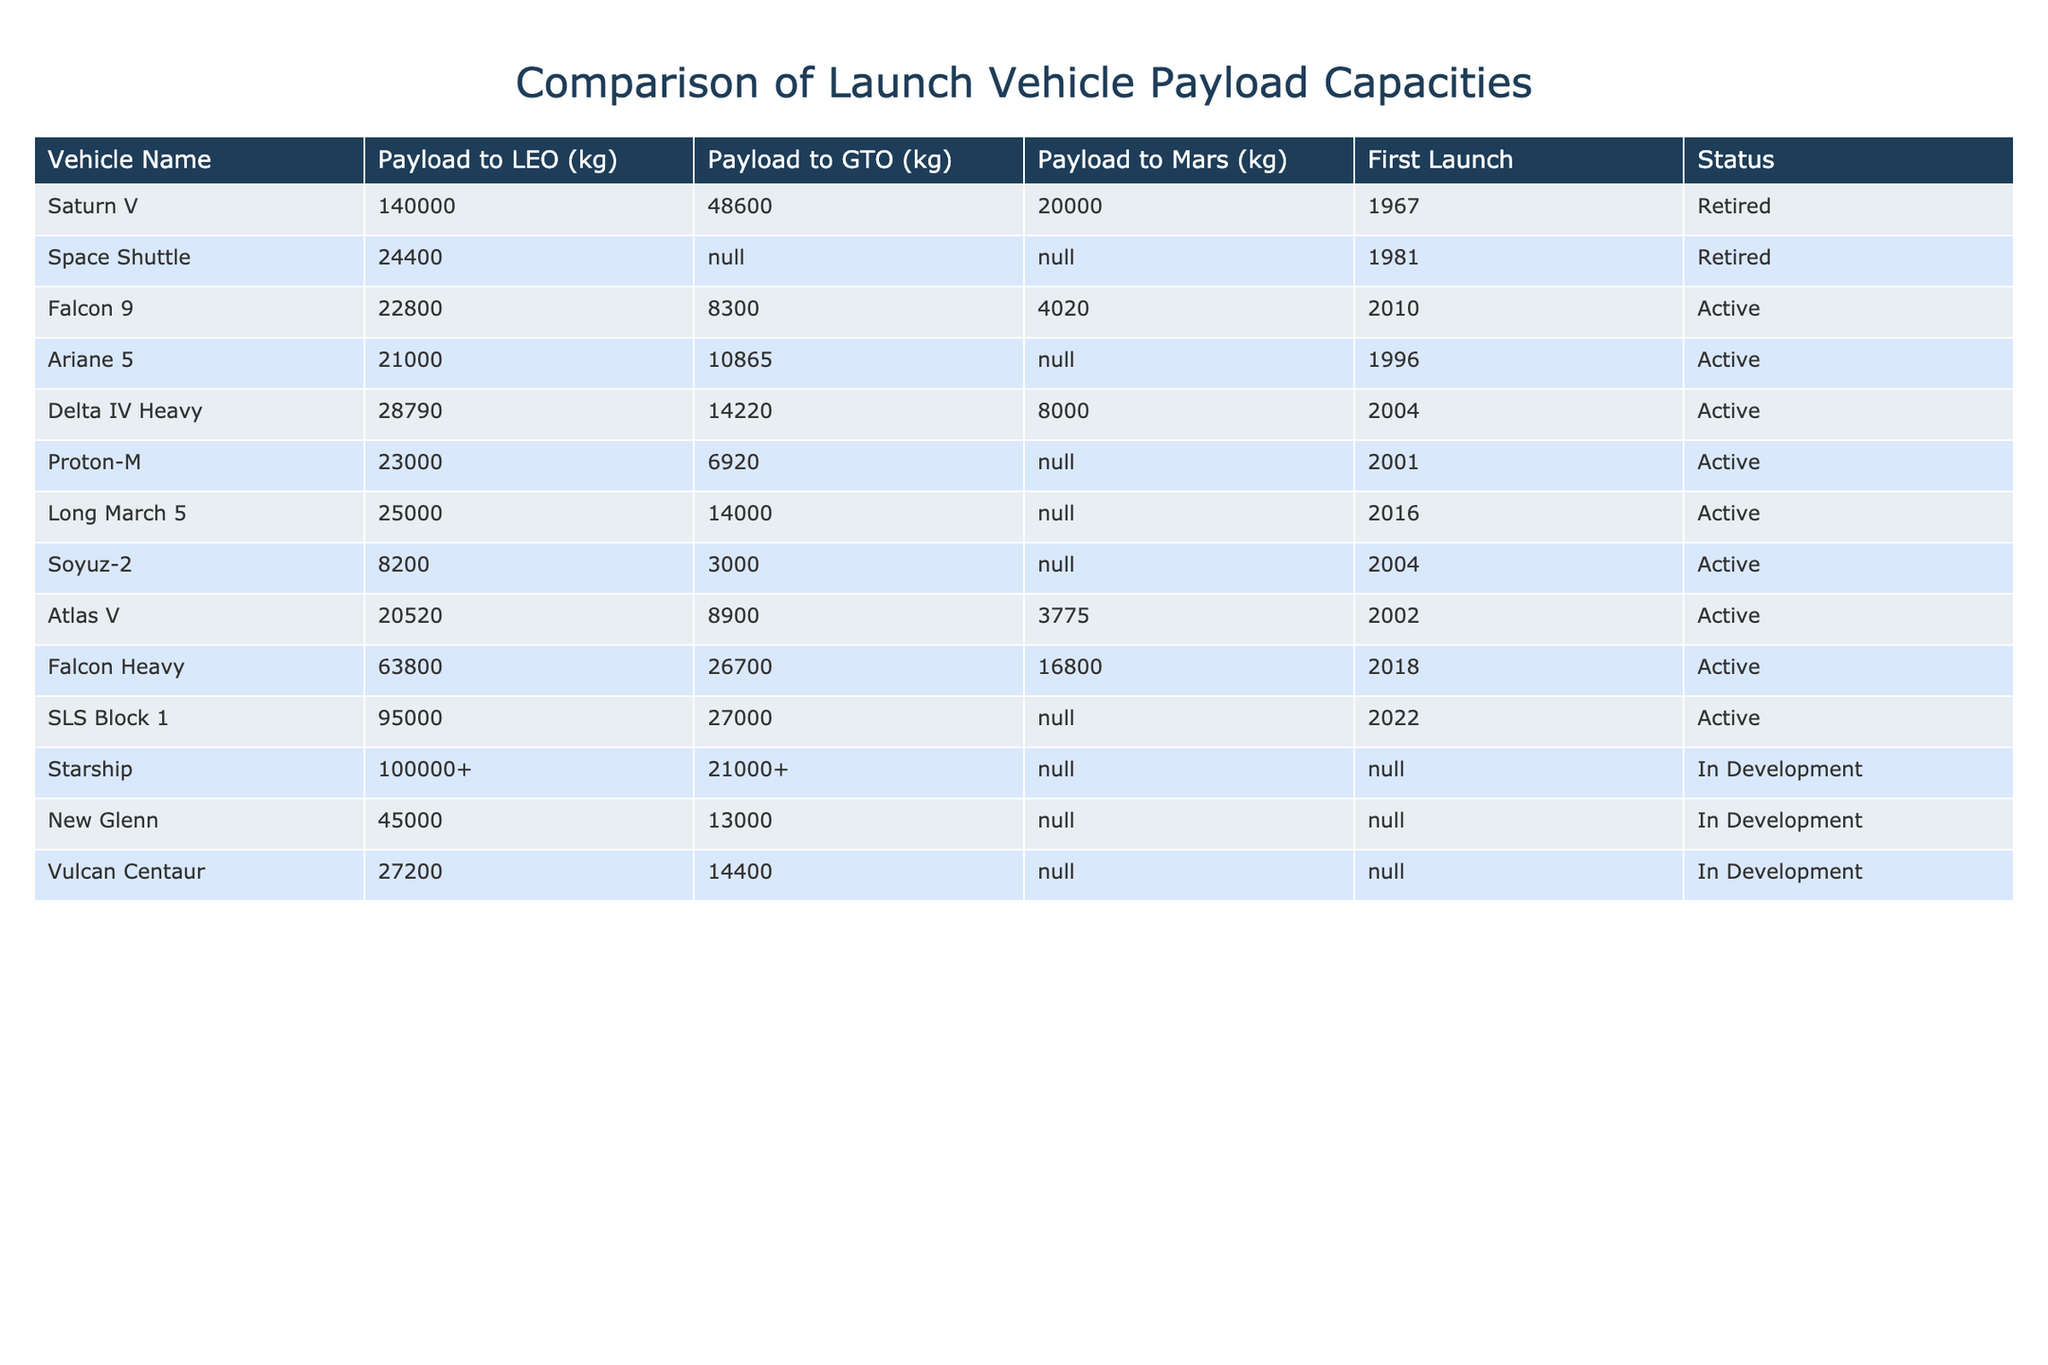What is the payload capacity to Low Earth Orbit for Saturn V? The payload capacity to Low Earth Orbit for Saturn V is listed in the table under the "Payload to LEO (kg)" column. This value is found directly next to the vehicle name Saturn V, which shows 140,000 kg.
Answer: 140000 kg Which vehicle has the highest payload to GTO? By inspecting the column "Payload to GTO (kg)", we see that Falcon Heavy has the highest payload capacity with a value of 26,700 kg, which is more than any other vehicle in that category.
Answer: 26700 kg Is the Space Shuttle still in service? The status of the Space Shuttle can be found in the "Status" column. The table indicates that the Space Shuttle is marked as "Retired." Therefore, it is no longer in service.
Answer: No What is the difference in payload capacity to Mars between the Falcon 9 and the Delta IV Heavy? First, we retrieve the payload capacities to Mars from the "Payload to Mars (kg)" column for both vehicles. Falcon 9 has 4,020 kg, while Delta IV Heavy has 8,000 kg. The difference is 8,000 kg - 4,020 kg = 3,980 kg.
Answer: 3980 kg Which launch vehicle was first launched in 1967 and what was its payload capacity to GTO? We look for the first launch year of 1967 in the "First Launch" column, which corresponds to the Saturn V vehicle. Checking the "Payload to GTO (kg)" column for Saturn V, we find it listed as 48,600 kg.
Answer: 48600 kg What is the average payload to LEO of all the vehicles listed in the table? We first collect all payload values in the "Payload to LEO (kg)" column, which are: 140000, 24400, 22800, 21000, 28790, 23000, 25000, 8200, 20520, 63800, 95000, 100000+, 45000, 27200. We convert 100000+ to 100000 and calculate the sum, which is 455410 kg. There are 14 vehicles, so the average is 455410 kg / 14 = 32408.57 kg, rounded to 32409 kg.
Answer: 32409 kg Which active launch vehicle has the lowest payload to GTO? In the "Status" column, we filter for active vehicles and then look at the "Payload to GTO (kg)" column for those vehicles. The lowest value is found for Soyuz-2, which has 3,000 kg.
Answer: 3000 kg Can you list all vehicles that have a payload capacity to Mars? We need to check the "Payload to Mars (kg)" column for non-N/A values. The vehicles with capacities are Falcon 9 (4020 kg), Delta IV Heavy (8000 kg), Falcon Heavy (16800 kg), and SLS Block 1 (N/A). The other vehicles have N/A or no capacity listed.
Answer: Falcon 9, Delta IV Heavy, Falcon Heavy, SLS Block 1 